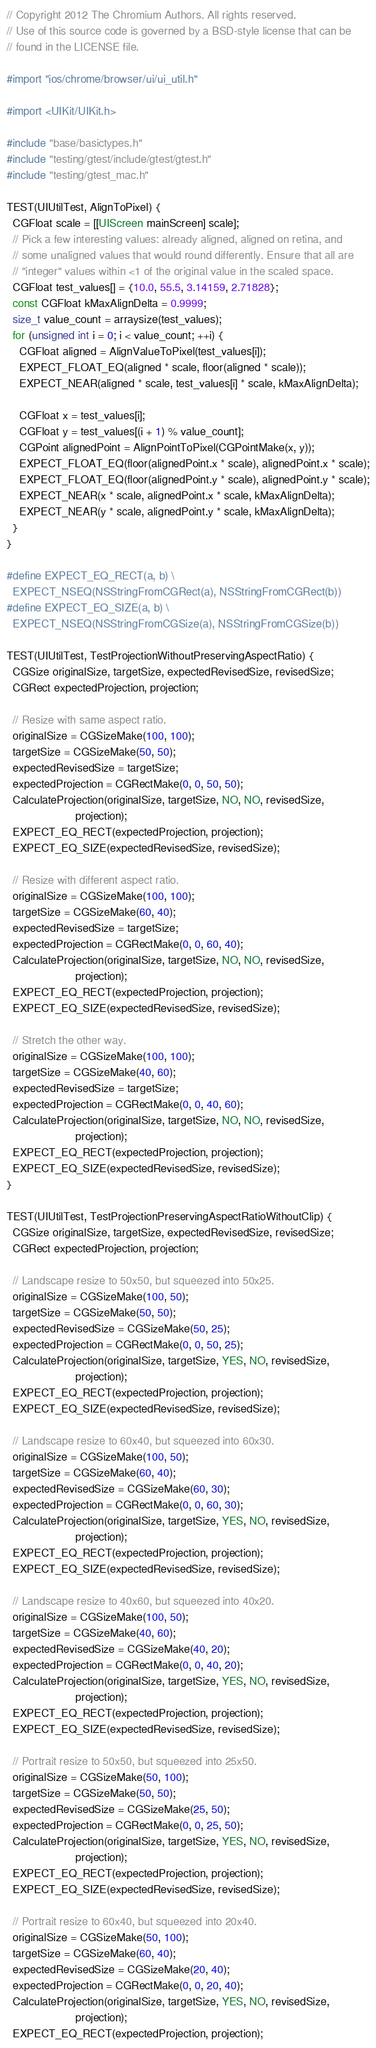<code> <loc_0><loc_0><loc_500><loc_500><_ObjectiveC_>// Copyright 2012 The Chromium Authors. All rights reserved.
// Use of this source code is governed by a BSD-style license that can be
// found in the LICENSE file.

#import "ios/chrome/browser/ui/ui_util.h"

#import <UIKit/UIKit.h>

#include "base/basictypes.h"
#include "testing/gtest/include/gtest/gtest.h"
#include "testing/gtest_mac.h"

TEST(UIUtilTest, AlignToPixel) {
  CGFloat scale = [[UIScreen mainScreen] scale];
  // Pick a few interesting values: already aligned, aligned on retina, and
  // some unaligned values that would round differently. Ensure that all are
  // "integer" values within <1 of the original value in the scaled space.
  CGFloat test_values[] = {10.0, 55.5, 3.14159, 2.71828};
  const CGFloat kMaxAlignDelta = 0.9999;
  size_t value_count = arraysize(test_values);
  for (unsigned int i = 0; i < value_count; ++i) {
    CGFloat aligned = AlignValueToPixel(test_values[i]);
    EXPECT_FLOAT_EQ(aligned * scale, floor(aligned * scale));
    EXPECT_NEAR(aligned * scale, test_values[i] * scale, kMaxAlignDelta);

    CGFloat x = test_values[i];
    CGFloat y = test_values[(i + 1) % value_count];
    CGPoint alignedPoint = AlignPointToPixel(CGPointMake(x, y));
    EXPECT_FLOAT_EQ(floor(alignedPoint.x * scale), alignedPoint.x * scale);
    EXPECT_FLOAT_EQ(floor(alignedPoint.y * scale), alignedPoint.y * scale);
    EXPECT_NEAR(x * scale, alignedPoint.x * scale, kMaxAlignDelta);
    EXPECT_NEAR(y * scale, alignedPoint.y * scale, kMaxAlignDelta);
  }
}

#define EXPECT_EQ_RECT(a, b) \
  EXPECT_NSEQ(NSStringFromCGRect(a), NSStringFromCGRect(b))
#define EXPECT_EQ_SIZE(a, b) \
  EXPECT_NSEQ(NSStringFromCGSize(a), NSStringFromCGSize(b))

TEST(UIUtilTest, TestProjectionWithoutPreservingAspectRatio) {
  CGSize originalSize, targetSize, expectedRevisedSize, revisedSize;
  CGRect expectedProjection, projection;

  // Resize with same aspect ratio.
  originalSize = CGSizeMake(100, 100);
  targetSize = CGSizeMake(50, 50);
  expectedRevisedSize = targetSize;
  expectedProjection = CGRectMake(0, 0, 50, 50);
  CalculateProjection(originalSize, targetSize, NO, NO, revisedSize,
                      projection);
  EXPECT_EQ_RECT(expectedProjection, projection);
  EXPECT_EQ_SIZE(expectedRevisedSize, revisedSize);

  // Resize with different aspect ratio.
  originalSize = CGSizeMake(100, 100);
  targetSize = CGSizeMake(60, 40);
  expectedRevisedSize = targetSize;
  expectedProjection = CGRectMake(0, 0, 60, 40);
  CalculateProjection(originalSize, targetSize, NO, NO, revisedSize,
                      projection);
  EXPECT_EQ_RECT(expectedProjection, projection);
  EXPECT_EQ_SIZE(expectedRevisedSize, revisedSize);

  // Stretch the other way.
  originalSize = CGSizeMake(100, 100);
  targetSize = CGSizeMake(40, 60);
  expectedRevisedSize = targetSize;
  expectedProjection = CGRectMake(0, 0, 40, 60);
  CalculateProjection(originalSize, targetSize, NO, NO, revisedSize,
                      projection);
  EXPECT_EQ_RECT(expectedProjection, projection);
  EXPECT_EQ_SIZE(expectedRevisedSize, revisedSize);
}

TEST(UIUtilTest, TestProjectionPreservingAspectRatioWithoutClip) {
  CGSize originalSize, targetSize, expectedRevisedSize, revisedSize;
  CGRect expectedProjection, projection;

  // Landscape resize to 50x50, but squeezed into 50x25.
  originalSize = CGSizeMake(100, 50);
  targetSize = CGSizeMake(50, 50);
  expectedRevisedSize = CGSizeMake(50, 25);
  expectedProjection = CGRectMake(0, 0, 50, 25);
  CalculateProjection(originalSize, targetSize, YES, NO, revisedSize,
                      projection);
  EXPECT_EQ_RECT(expectedProjection, projection);
  EXPECT_EQ_SIZE(expectedRevisedSize, revisedSize);

  // Landscape resize to 60x40, but squeezed into 60x30.
  originalSize = CGSizeMake(100, 50);
  targetSize = CGSizeMake(60, 40);
  expectedRevisedSize = CGSizeMake(60, 30);
  expectedProjection = CGRectMake(0, 0, 60, 30);
  CalculateProjection(originalSize, targetSize, YES, NO, revisedSize,
                      projection);
  EXPECT_EQ_RECT(expectedProjection, projection);
  EXPECT_EQ_SIZE(expectedRevisedSize, revisedSize);

  // Landscape resize to 40x60, but squeezed into 40x20.
  originalSize = CGSizeMake(100, 50);
  targetSize = CGSizeMake(40, 60);
  expectedRevisedSize = CGSizeMake(40, 20);
  expectedProjection = CGRectMake(0, 0, 40, 20);
  CalculateProjection(originalSize, targetSize, YES, NO, revisedSize,
                      projection);
  EXPECT_EQ_RECT(expectedProjection, projection);
  EXPECT_EQ_SIZE(expectedRevisedSize, revisedSize);

  // Portrait resize to 50x50, but squeezed into 25x50.
  originalSize = CGSizeMake(50, 100);
  targetSize = CGSizeMake(50, 50);
  expectedRevisedSize = CGSizeMake(25, 50);
  expectedProjection = CGRectMake(0, 0, 25, 50);
  CalculateProjection(originalSize, targetSize, YES, NO, revisedSize,
                      projection);
  EXPECT_EQ_RECT(expectedProjection, projection);
  EXPECT_EQ_SIZE(expectedRevisedSize, revisedSize);

  // Portrait resize to 60x40, but squeezed into 20x40.
  originalSize = CGSizeMake(50, 100);
  targetSize = CGSizeMake(60, 40);
  expectedRevisedSize = CGSizeMake(20, 40);
  expectedProjection = CGRectMake(0, 0, 20, 40);
  CalculateProjection(originalSize, targetSize, YES, NO, revisedSize,
                      projection);
  EXPECT_EQ_RECT(expectedProjection, projection);</code> 